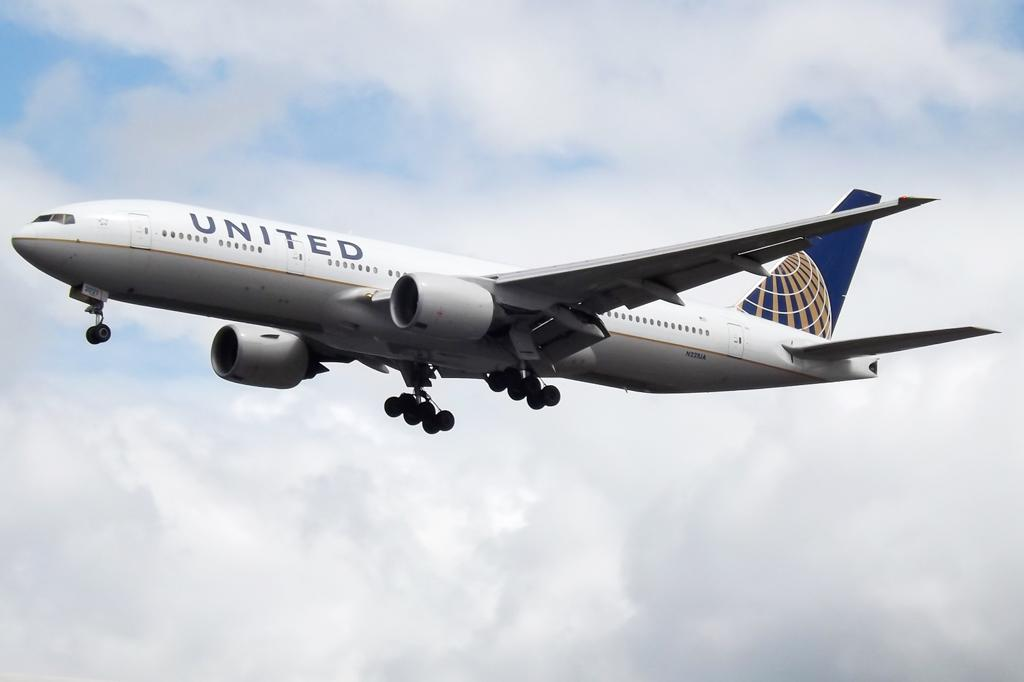<image>
Present a compact description of the photo's key features. A United airplane descending through the clouds to the landing strip. 